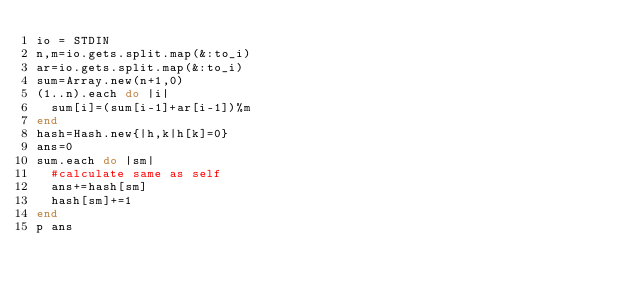<code> <loc_0><loc_0><loc_500><loc_500><_Ruby_>io = STDIN
n,m=io.gets.split.map(&:to_i)
ar=io.gets.split.map(&:to_i)
sum=Array.new(n+1,0)
(1..n).each do |i|
  sum[i]=(sum[i-1]+ar[i-1])%m
end
hash=Hash.new{|h,k|h[k]=0}
ans=0
sum.each do |sm|
  #calculate same as self
  ans+=hash[sm]
  hash[sm]+=1
end
p ans
</code> 